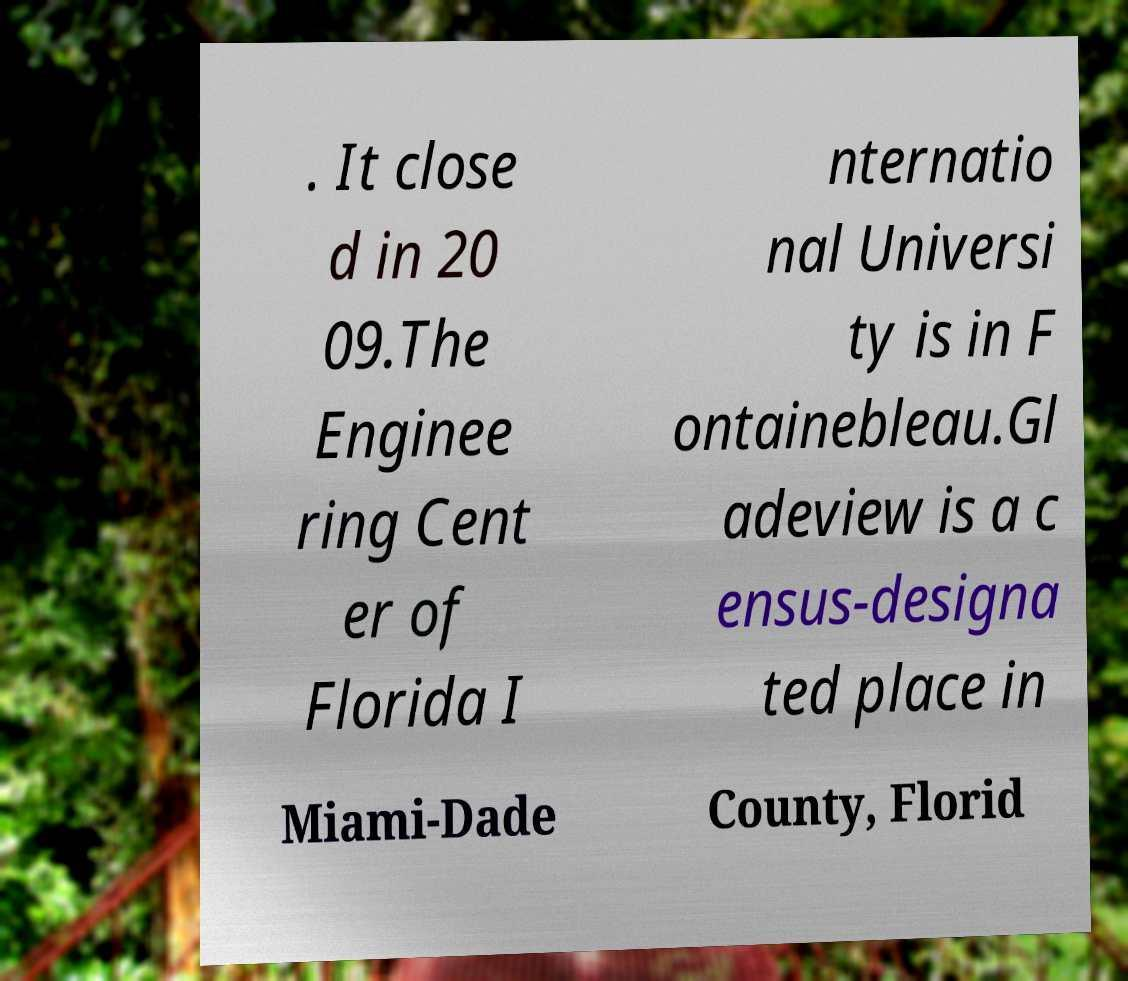Please read and relay the text visible in this image. What does it say? . It close d in 20 09.The Enginee ring Cent er of Florida I nternatio nal Universi ty is in F ontainebleau.Gl adeview is a c ensus-designa ted place in Miami-Dade County, Florid 